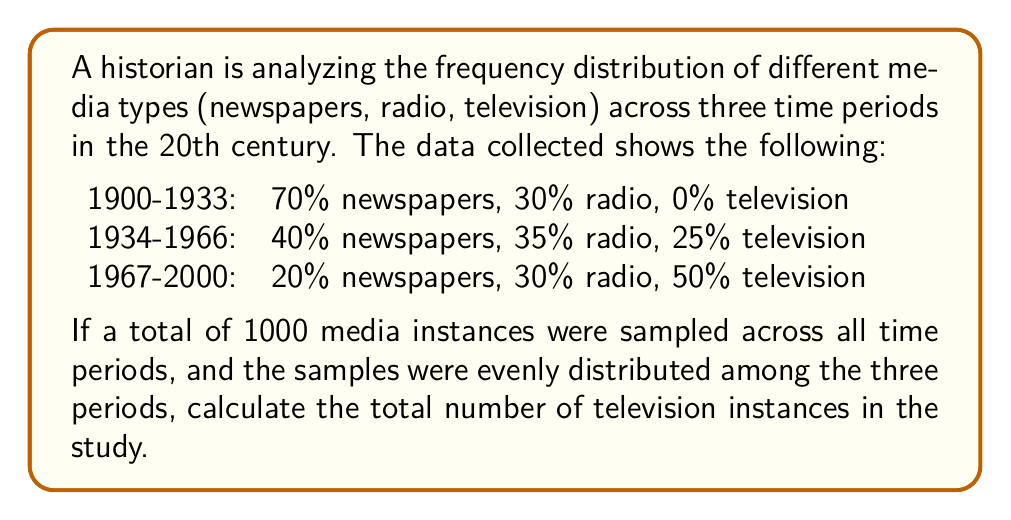Show me your answer to this math problem. Let's approach this step-by-step:

1) First, we need to determine how many media instances were sampled in each time period:
   $$\frac{1000 \text{ total instances}}{3 \text{ time periods}} = 333.33 \text{ instances per period}$$
   
   We'll round this to 333 instances per period for simplicity.

2) Now, let's calculate the number of television instances for each period:

   1900-1933: $333 \times 0\% = 0$ instances
   1934-1966: $333 \times 25\% = 333 \times 0.25 = 83.25$ instances
   1967-2000: $333 \times 50\% = 333 \times 0.5 = 166.5$ instances

3) To get the total number of television instances, we sum these up:

   $$0 + 83.25 + 166.5 = 249.75$$

4) Since we can't have fractional media instances, we round this to the nearest whole number:

   $$250 \text{ television instances}$$
Answer: 250 